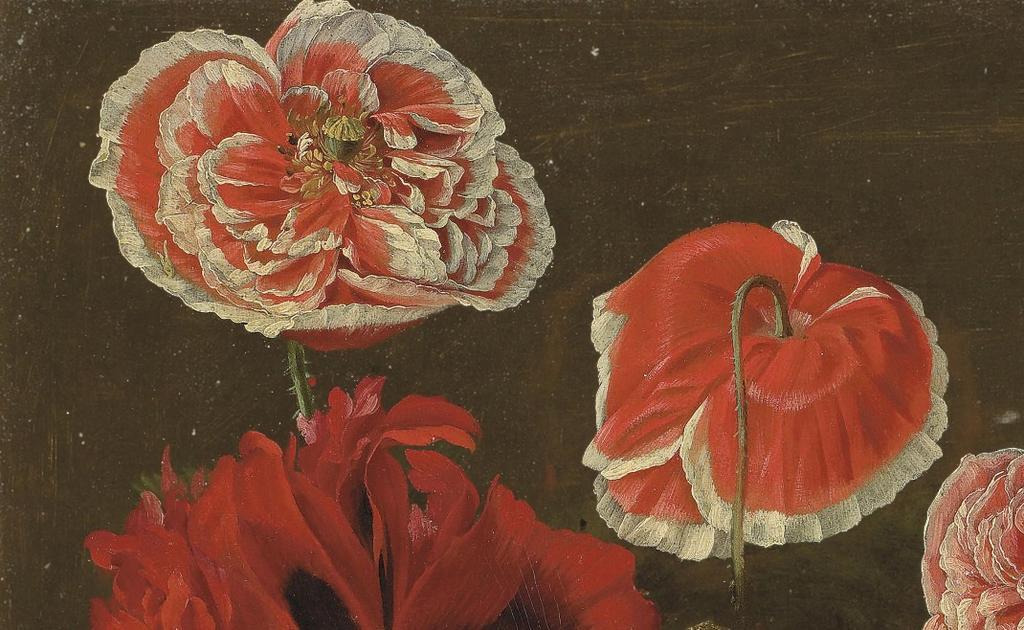Can you describe this image briefly? This picture looks like a painting, I can see flowers and I can see dark background. 